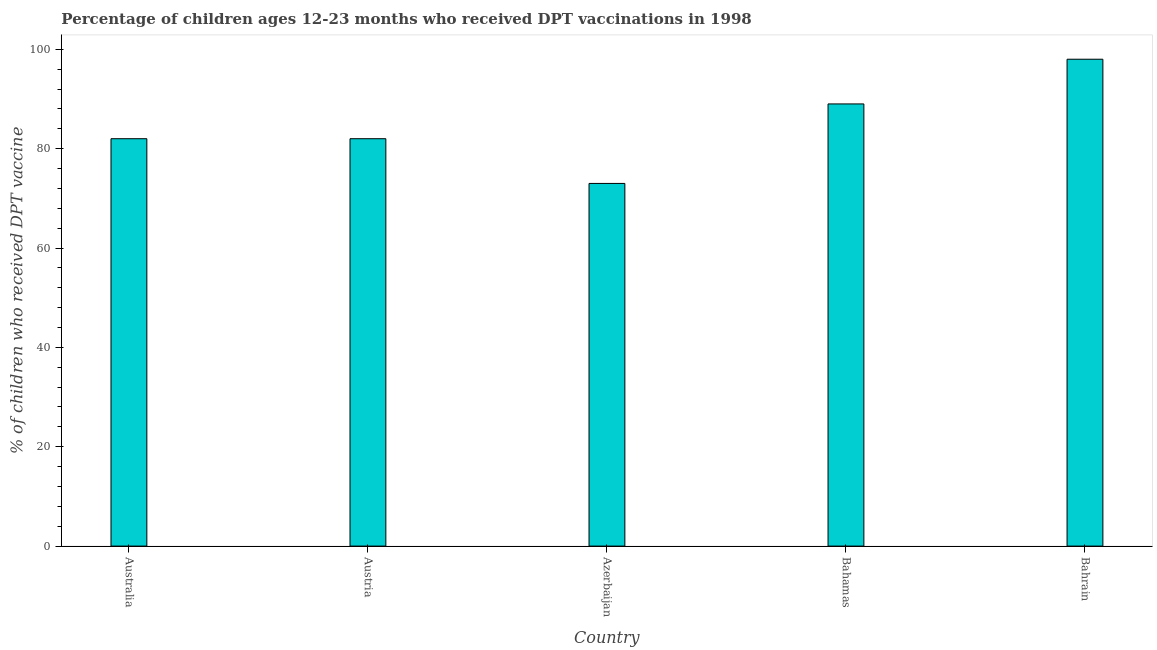Does the graph contain any zero values?
Offer a terse response. No. What is the title of the graph?
Provide a succinct answer. Percentage of children ages 12-23 months who received DPT vaccinations in 1998. What is the label or title of the X-axis?
Your answer should be compact. Country. What is the label or title of the Y-axis?
Give a very brief answer. % of children who received DPT vaccine. What is the percentage of children who received dpt vaccine in Australia?
Provide a succinct answer. 82. Across all countries, what is the minimum percentage of children who received dpt vaccine?
Keep it short and to the point. 73. In which country was the percentage of children who received dpt vaccine maximum?
Keep it short and to the point. Bahrain. In which country was the percentage of children who received dpt vaccine minimum?
Your response must be concise. Azerbaijan. What is the sum of the percentage of children who received dpt vaccine?
Your response must be concise. 424. What is the average percentage of children who received dpt vaccine per country?
Ensure brevity in your answer.  84.8. What is the median percentage of children who received dpt vaccine?
Ensure brevity in your answer.  82. In how many countries, is the percentage of children who received dpt vaccine greater than 40 %?
Keep it short and to the point. 5. What is the ratio of the percentage of children who received dpt vaccine in Australia to that in Bahrain?
Your answer should be compact. 0.84. Is the percentage of children who received dpt vaccine in Australia less than that in Austria?
Ensure brevity in your answer.  No. Is the sum of the percentage of children who received dpt vaccine in Azerbaijan and Bahamas greater than the maximum percentage of children who received dpt vaccine across all countries?
Make the answer very short. Yes. What is the difference between the highest and the lowest percentage of children who received dpt vaccine?
Offer a terse response. 25. How many bars are there?
Your answer should be very brief. 5. Are all the bars in the graph horizontal?
Keep it short and to the point. No. How many countries are there in the graph?
Your answer should be compact. 5. What is the difference between two consecutive major ticks on the Y-axis?
Your response must be concise. 20. Are the values on the major ticks of Y-axis written in scientific E-notation?
Keep it short and to the point. No. What is the % of children who received DPT vaccine in Austria?
Provide a succinct answer. 82. What is the % of children who received DPT vaccine in Bahamas?
Offer a terse response. 89. What is the % of children who received DPT vaccine in Bahrain?
Offer a very short reply. 98. What is the difference between the % of children who received DPT vaccine in Australia and Bahamas?
Make the answer very short. -7. What is the difference between the % of children who received DPT vaccine in Australia and Bahrain?
Your response must be concise. -16. What is the difference between the % of children who received DPT vaccine in Austria and Bahamas?
Your answer should be compact. -7. What is the difference between the % of children who received DPT vaccine in Austria and Bahrain?
Your answer should be compact. -16. What is the difference between the % of children who received DPT vaccine in Azerbaijan and Bahrain?
Provide a succinct answer. -25. What is the difference between the % of children who received DPT vaccine in Bahamas and Bahrain?
Provide a short and direct response. -9. What is the ratio of the % of children who received DPT vaccine in Australia to that in Azerbaijan?
Offer a terse response. 1.12. What is the ratio of the % of children who received DPT vaccine in Australia to that in Bahamas?
Your response must be concise. 0.92. What is the ratio of the % of children who received DPT vaccine in Australia to that in Bahrain?
Offer a terse response. 0.84. What is the ratio of the % of children who received DPT vaccine in Austria to that in Azerbaijan?
Provide a succinct answer. 1.12. What is the ratio of the % of children who received DPT vaccine in Austria to that in Bahamas?
Provide a succinct answer. 0.92. What is the ratio of the % of children who received DPT vaccine in Austria to that in Bahrain?
Give a very brief answer. 0.84. What is the ratio of the % of children who received DPT vaccine in Azerbaijan to that in Bahamas?
Ensure brevity in your answer.  0.82. What is the ratio of the % of children who received DPT vaccine in Azerbaijan to that in Bahrain?
Ensure brevity in your answer.  0.74. What is the ratio of the % of children who received DPT vaccine in Bahamas to that in Bahrain?
Make the answer very short. 0.91. 